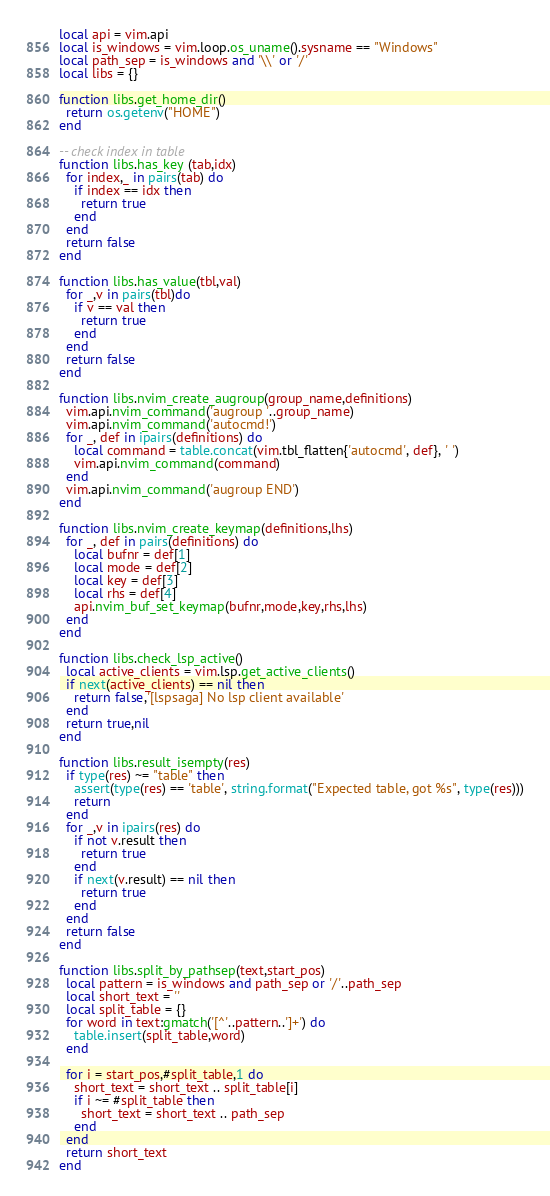<code> <loc_0><loc_0><loc_500><loc_500><_Lua_>local api = vim.api
local is_windows = vim.loop.os_uname().sysname == "Windows"
local path_sep = is_windows and '\\' or '/'
local libs = {}

function libs.get_home_dir()
  return os.getenv("HOME")
end

-- check index in table
function libs.has_key (tab,idx)
  for index,_ in pairs(tab) do
    if index == idx then
      return true
    end
  end
  return false
end

function libs.has_value(tbl,val)
  for _,v in pairs(tbl)do
    if v == val then
      return true
    end
  end
  return false
end

function libs.nvim_create_augroup(group_name,definitions)
  vim.api.nvim_command('augroup '..group_name)
  vim.api.nvim_command('autocmd!')
  for _, def in ipairs(definitions) do
    local command = table.concat(vim.tbl_flatten{'autocmd', def}, ' ')
    vim.api.nvim_command(command)
  end
  vim.api.nvim_command('augroup END')
end

function libs.nvim_create_keymap(definitions,lhs)
  for _, def in pairs(definitions) do
    local bufnr = def[1]
    local mode = def[2]
    local key = def[3]
    local rhs = def[4]
    api.nvim_buf_set_keymap(bufnr,mode,key,rhs,lhs)
  end
end

function libs.check_lsp_active()
  local active_clients = vim.lsp.get_active_clients()
  if next(active_clients) == nil then
    return false,'[lspsaga] No lsp client available'
  end
  return true,nil
end

function libs.result_isempty(res)
  if type(res) ~= "table" then
    assert(type(res) == 'table', string.format("Expected table, got %s", type(res)))
    return
  end
  for _,v in ipairs(res) do
    if not v.result then
      return true
    end
    if next(v.result) == nil then
      return true
    end
  end
  return false
end

function libs.split_by_pathsep(text,start_pos)
  local pattern = is_windows and path_sep or '/'..path_sep
  local short_text = ''
  local split_table = {}
  for word in text:gmatch('[^'..pattern..']+') do
    table.insert(split_table,word)
  end

  for i = start_pos,#split_table,1 do
    short_text = short_text .. split_table[i]
    if i ~= #split_table then
      short_text = short_text .. path_sep
    end
  end
  return short_text
end
</code> 